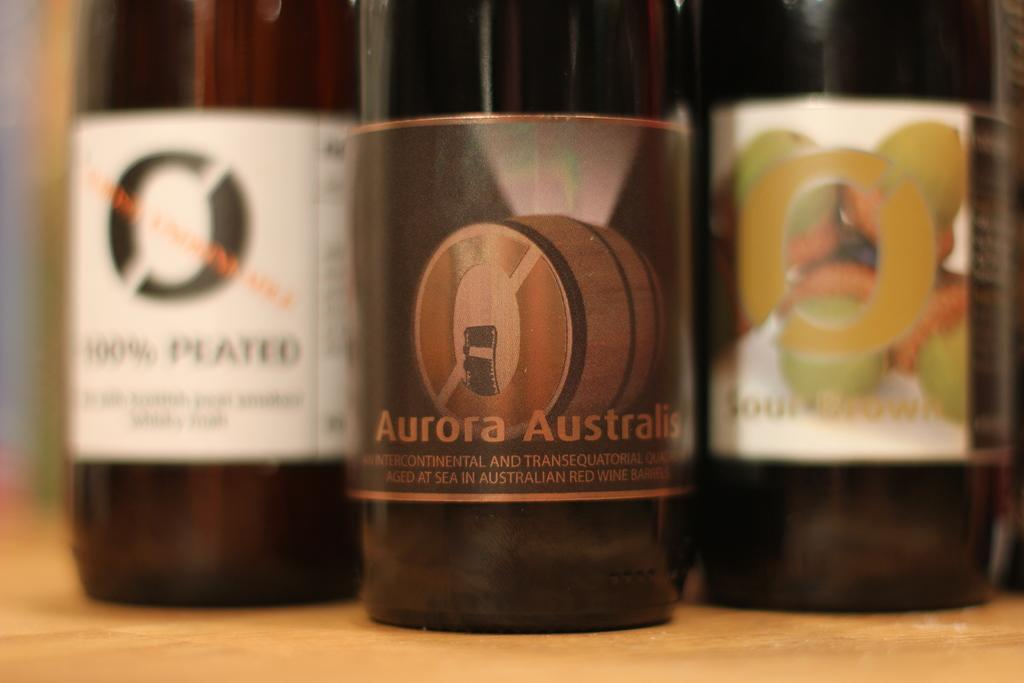<image>
Give a short and clear explanation of the subsequent image. A bottle of Aurora Australis sits with some other bottles of wine. 